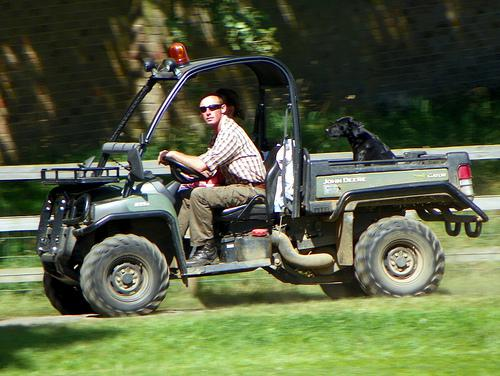Question: how many people in vehicle?
Choices:
A. Two.
B. Three.
C. Four.
D. One.
Answer with the letter. Answer: D Question: who is driving the vehicle?
Choices:
A. A woman.
B. A boy.
C. A girl.
D. A man.
Answer with the letter. Answer: D Question: where is the brick building?
Choices:
A. In front of the vehicle.
B. Behind the vehicle.
C. Next to the vehicle.
D. Near the vehicle.
Answer with the letter. Answer: B Question: what color is the grass?
Choices:
A. Brown.
B. Red.
C. White.
D. Green.
Answer with the letter. Answer: D 